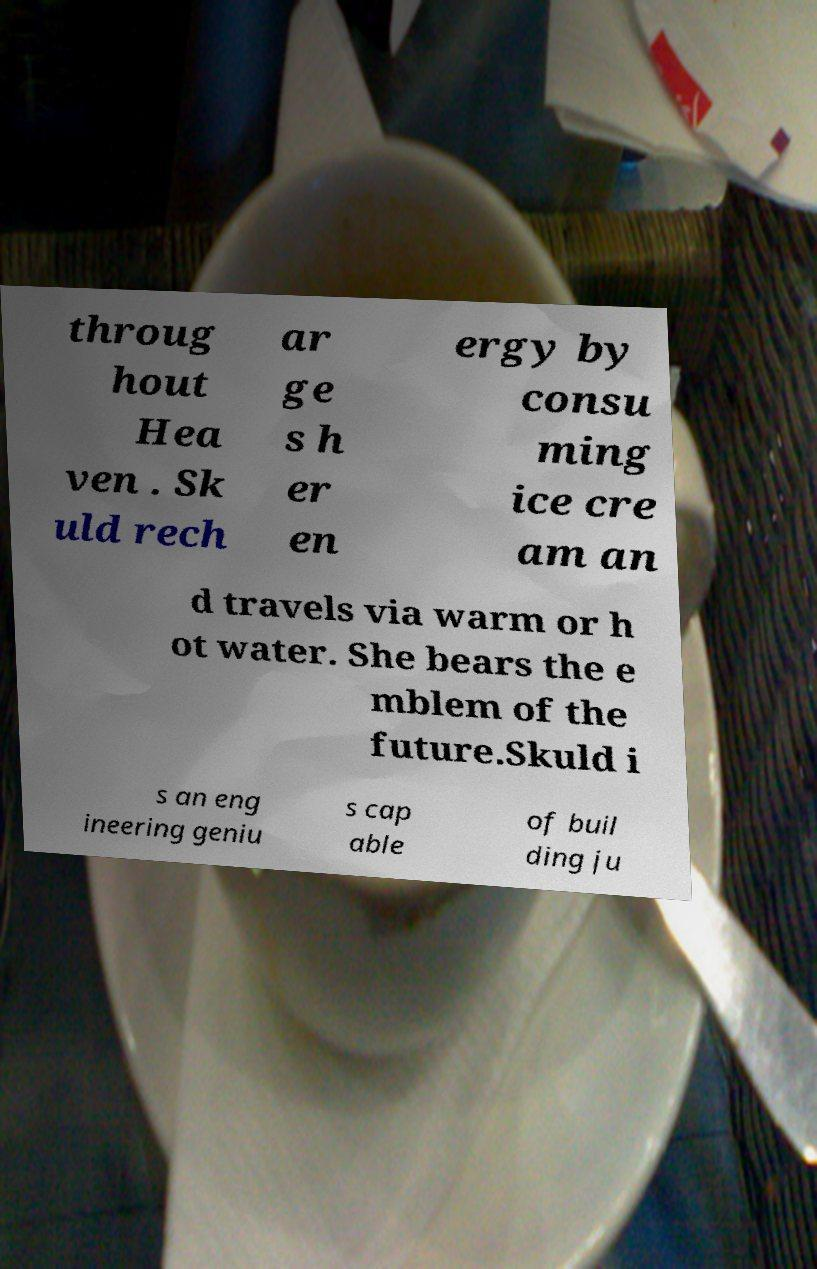What messages or text are displayed in this image? I need them in a readable, typed format. throug hout Hea ven . Sk uld rech ar ge s h er en ergy by consu ming ice cre am an d travels via warm or h ot water. She bears the e mblem of the future.Skuld i s an eng ineering geniu s cap able of buil ding ju 